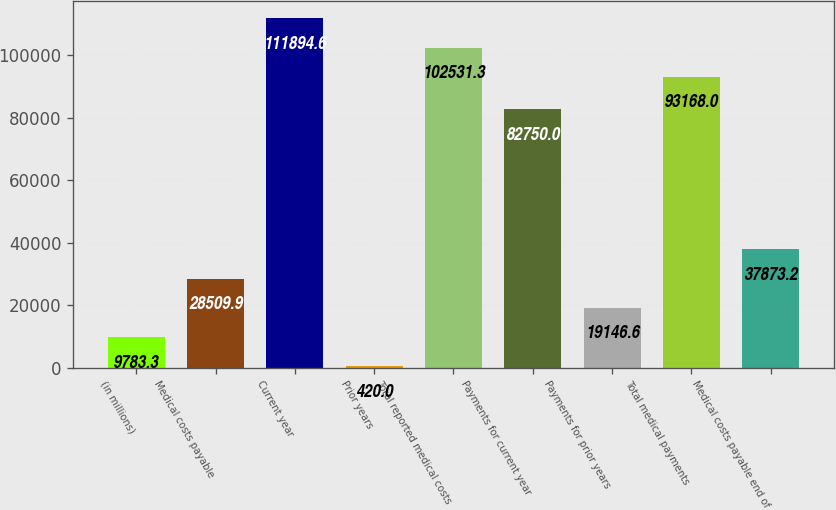Convert chart. <chart><loc_0><loc_0><loc_500><loc_500><bar_chart><fcel>(in millions)<fcel>Medical costs payable<fcel>Current year<fcel>Prior years<fcel>Total reported medical costs<fcel>Payments for current year<fcel>Payments for prior years<fcel>Total medical payments<fcel>Medical costs payable end of<nl><fcel>9783.3<fcel>28509.9<fcel>111895<fcel>420<fcel>102531<fcel>82750<fcel>19146.6<fcel>93168<fcel>37873.2<nl></chart> 